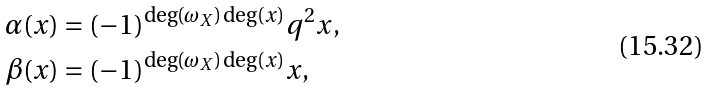Convert formula to latex. <formula><loc_0><loc_0><loc_500><loc_500>\alpha ( x ) & = ( - 1 ) ^ { \deg ( \omega _ { X } ) \deg ( x ) } q ^ { 2 } x , \\ \beta ( x ) & = ( - 1 ) ^ { \deg ( \omega _ { X } ) \deg ( x ) } x ,</formula> 